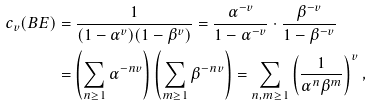<formula> <loc_0><loc_0><loc_500><loc_500>c _ { v } ( B E ) & = \frac { 1 } { ( 1 - \alpha ^ { v } ) ( 1 - \beta ^ { v } ) } = \frac { \alpha ^ { - v } } { 1 - \alpha ^ { - v } } \cdot \frac { \beta ^ { - v } } { 1 - \beta ^ { - v } } \\ & = \left ( \sum _ { n \geq 1 } \alpha ^ { - n v } \right ) \left ( \sum _ { m \geq 1 } \beta ^ { - n v } \right ) = \sum _ { n , m \geq 1 } \left ( \frac { 1 } { \alpha ^ { n } \beta ^ { m } } \right ) ^ { v } ,</formula> 